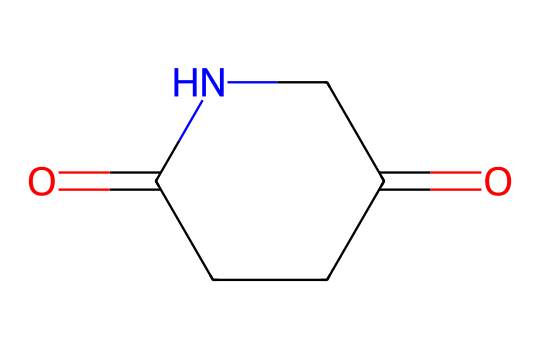What is the number of carbon atoms in glutarimide? The SMILES representation shows O=C1CCC(=O)NC1. Counting the "C" characters in the structure reveals there are four carbon atoms.
Answer: four How many nitrogen atoms are present in this chemical? In the provided SMILES, only one "N" is visible, indicating that there is one nitrogen atom in the glutarimide structure.
Answer: one What type of functional group is present in glutarimide? The SMILES notation indicates that this compound has carbonyl groups (C=O) as well as amide (C=O attached to N) functionalities. Thus, it has both a carbonyl and an amide functional group, characteristic of imides.
Answer: imide Is glutarimide a cyclic compound? The notation "C1" and "NC1" in the SMILES suggests that the structure contains a ring where the first atom connects back to itself, defining a cyclic compound.
Answer: yes What is the total number of bonds formed by the nitrogen atom in glutarimide? The nitrogen atom is bonded to one carbon atom (part of the imide), and it can make three additional bonds. In this case, it forms one bond to carbon (the imide structure), leading to two other implicit hydrogen bonds, yielding three total.
Answer: three What is the oxidation state of the carbonyl carbon in glutarimide? The carbon in the carbonyl (C=O) is in the highest oxidation state, which for a carbonyl is typically +2. Thus, the oxidation state of that carbon atom is +2.
Answer: two 